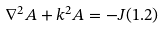Convert formula to latex. <formula><loc_0><loc_0><loc_500><loc_500>\nabla ^ { 2 } A + k ^ { 2 } A = - J ( 1 . 2 )</formula> 